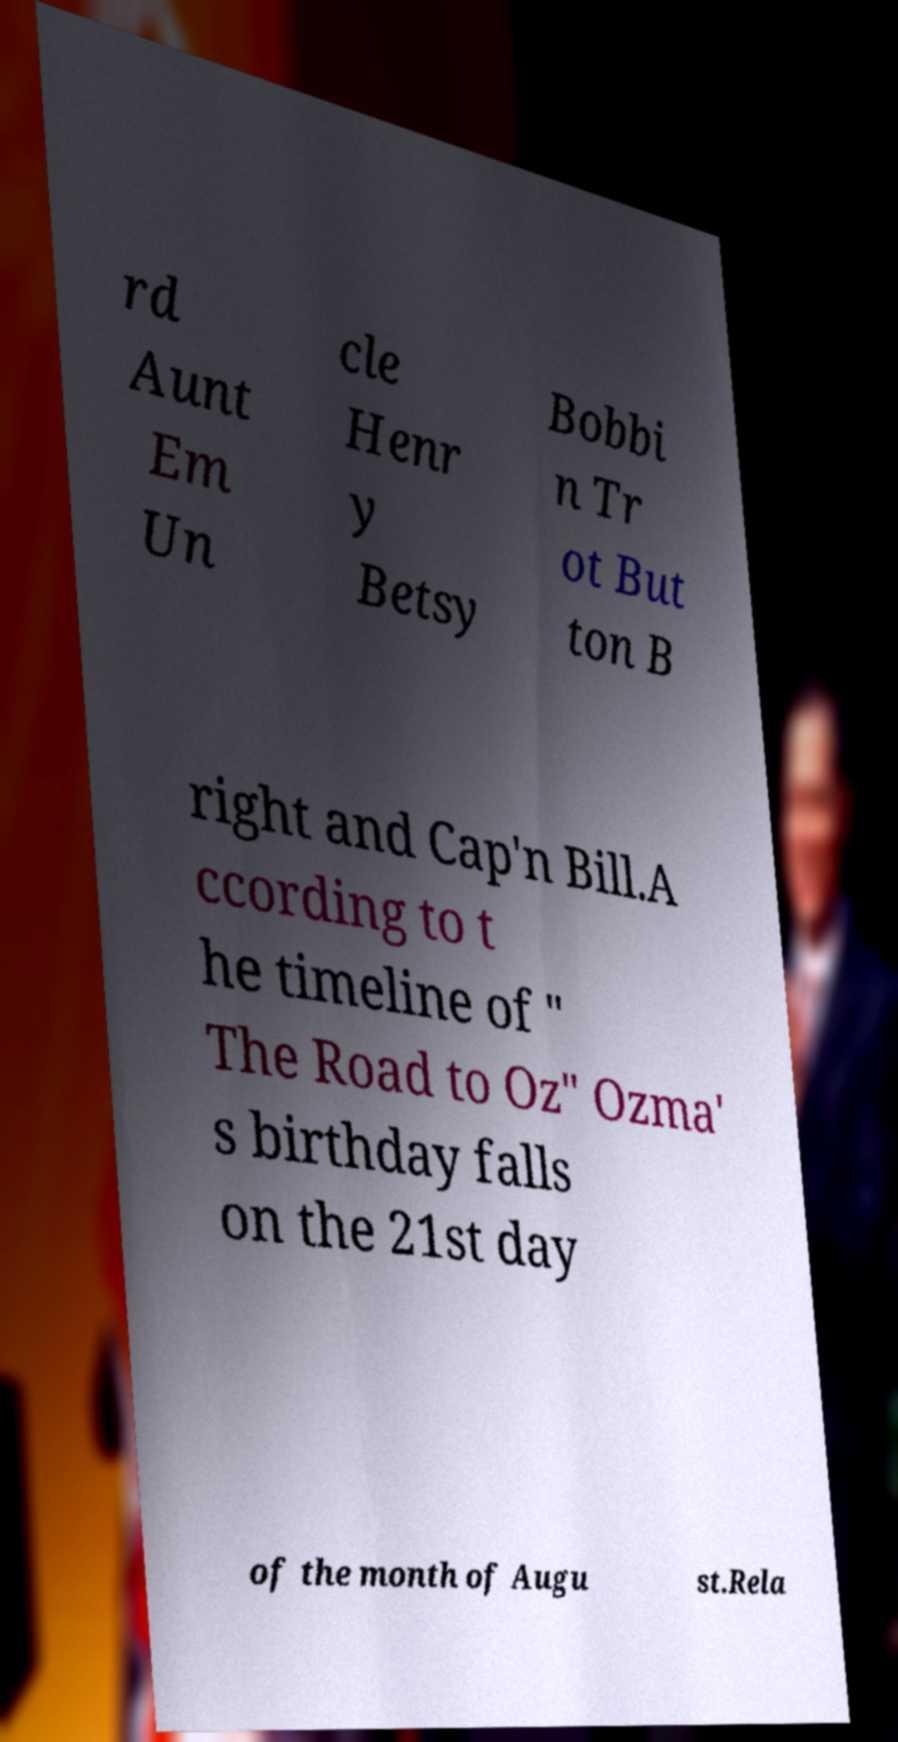Can you read and provide the text displayed in the image?This photo seems to have some interesting text. Can you extract and type it out for me? rd Aunt Em Un cle Henr y Betsy Bobbi n Tr ot But ton B right and Cap'n Bill.A ccording to t he timeline of " The Road to Oz" Ozma' s birthday falls on the 21st day of the month of Augu st.Rela 